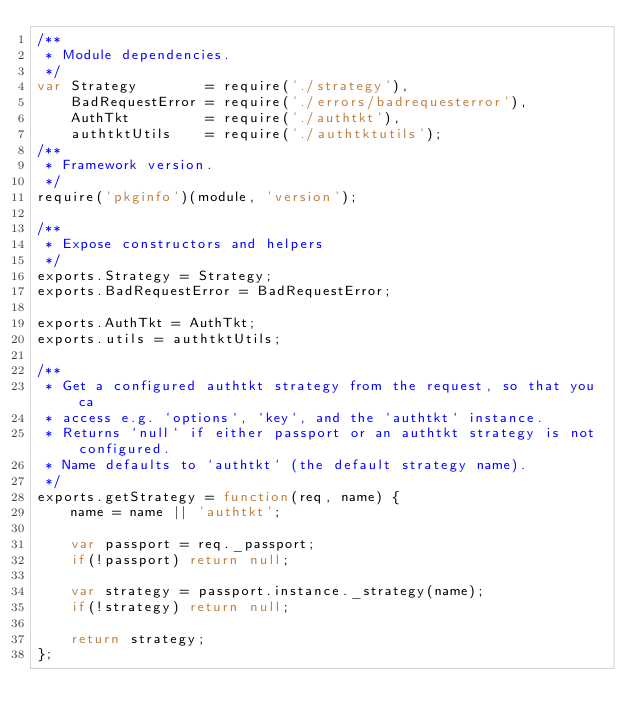<code> <loc_0><loc_0><loc_500><loc_500><_JavaScript_>/**
 * Module dependencies.
 */
var Strategy        = require('./strategy'),
    BadRequestError = require('./errors/badrequesterror'),
    AuthTkt         = require('./authtkt'),
    authtktUtils    = require('./authtktutils');
/**
 * Framework version.
 */
require('pkginfo')(module, 'version');

/**
 * Expose constructors and helpers
 */
exports.Strategy = Strategy;
exports.BadRequestError = BadRequestError;

exports.AuthTkt = AuthTkt;
exports.utils = authtktUtils;

/**
 * Get a configured authtkt strategy from the request, so that you ca
 * access e.g. `options`, `key`, and the `authtkt` instance.
 * Returns `null` if either passport or an authtkt strategy is not configured.
 * Name defaults to `authtkt` (the default strategy name).
 */
exports.getStrategy = function(req, name) {
    name = name || 'authtkt';
    
    var passport = req._passport;
    if(!passport) return null;

    var strategy = passport.instance._strategy(name);
    if(!strategy) return null;

    return strategy;
};</code> 